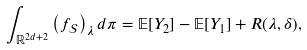<formula> <loc_0><loc_0><loc_500><loc_500>\int _ { \mathbb { R } ^ { 2 d + 2 } } \left ( f _ { \mathcal { S } } \right ) _ { \lambda } d \pi = \mathbb { E } [ Y _ { 2 } ] - \mathbb { E } [ Y _ { 1 } ] + R ( \lambda , \delta ) ,</formula> 